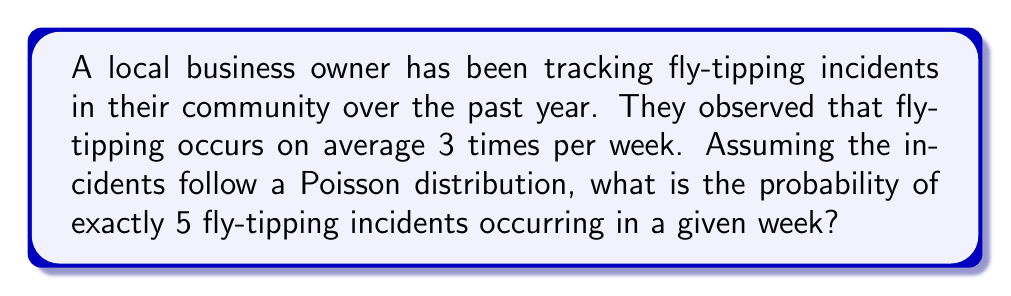Solve this math problem. To solve this problem, we'll use the Poisson distribution, which is appropriate for modeling the number of events occurring in a fixed interval of time or space when these events happen with a known average rate and independently of each other.

The Poisson probability mass function is given by:

$$P(X = k) = \frac{e^{-\lambda} \lambda^k}{k!}$$

Where:
$\lambda$ = average number of events per interval
$k$ = number of events we're calculating the probability for
$e$ = Euler's number (approximately 2.71828)

Given:
$\lambda = 3$ (average of 3 fly-tipping incidents per week)
$k = 5$ (we're calculating the probability of exactly 5 incidents)

Let's substitute these values into the formula:

$$P(X = 5) = \frac{e^{-3} 3^5}{5!}$$

Now, let's calculate step by step:

1. Calculate $3^5 = 243$
2. Calculate $5! = 5 \times 4 \times 3 \times 2 \times 1 = 120$
3. Calculate $e^{-3} \approx 0.0497871$

Substituting these values:

$$P(X = 5) = \frac{0.0497871 \times 243}{120}$$

$$P(X = 5) = \frac{12.0982653}{120}$$

$$P(X = 5) \approx 0.1008189$$

Therefore, the probability of exactly 5 fly-tipping incidents occurring in a given week is approximately 0.1008 or 10.08%.
Answer: 0.1008 or 10.08% 